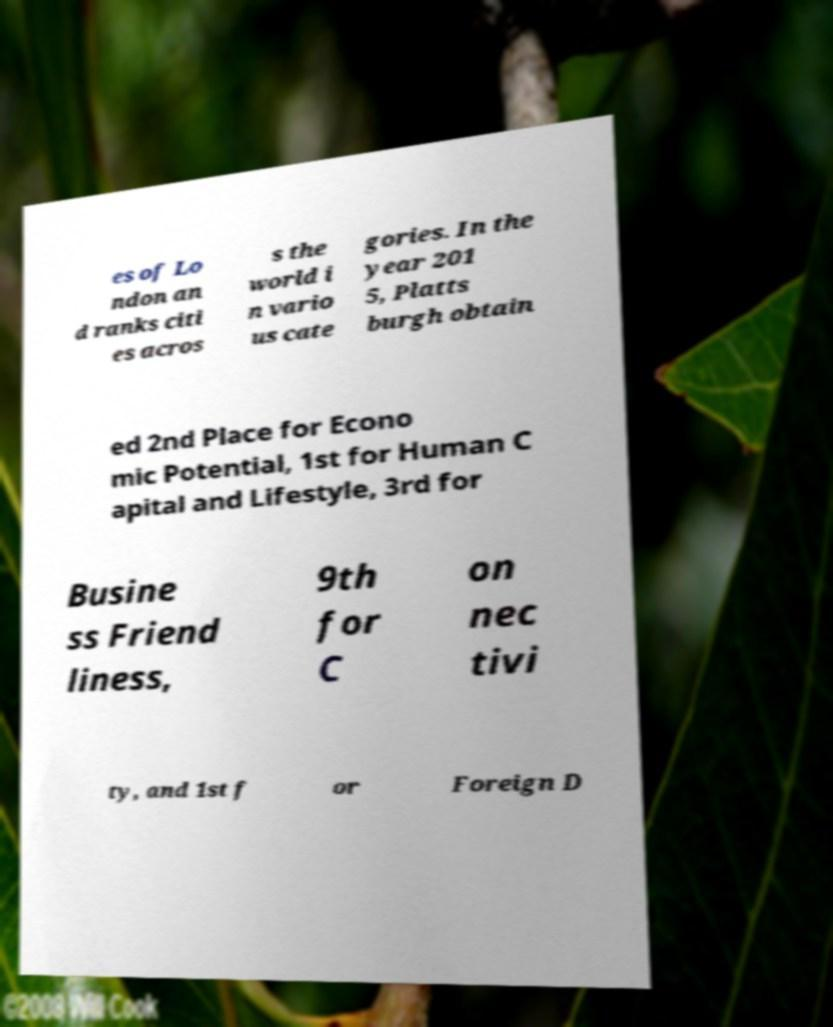For documentation purposes, I need the text within this image transcribed. Could you provide that? es of Lo ndon an d ranks citi es acros s the world i n vario us cate gories. In the year 201 5, Platts burgh obtain ed 2nd Place for Econo mic Potential, 1st for Human C apital and Lifestyle, 3rd for Busine ss Friend liness, 9th for C on nec tivi ty, and 1st f or Foreign D 